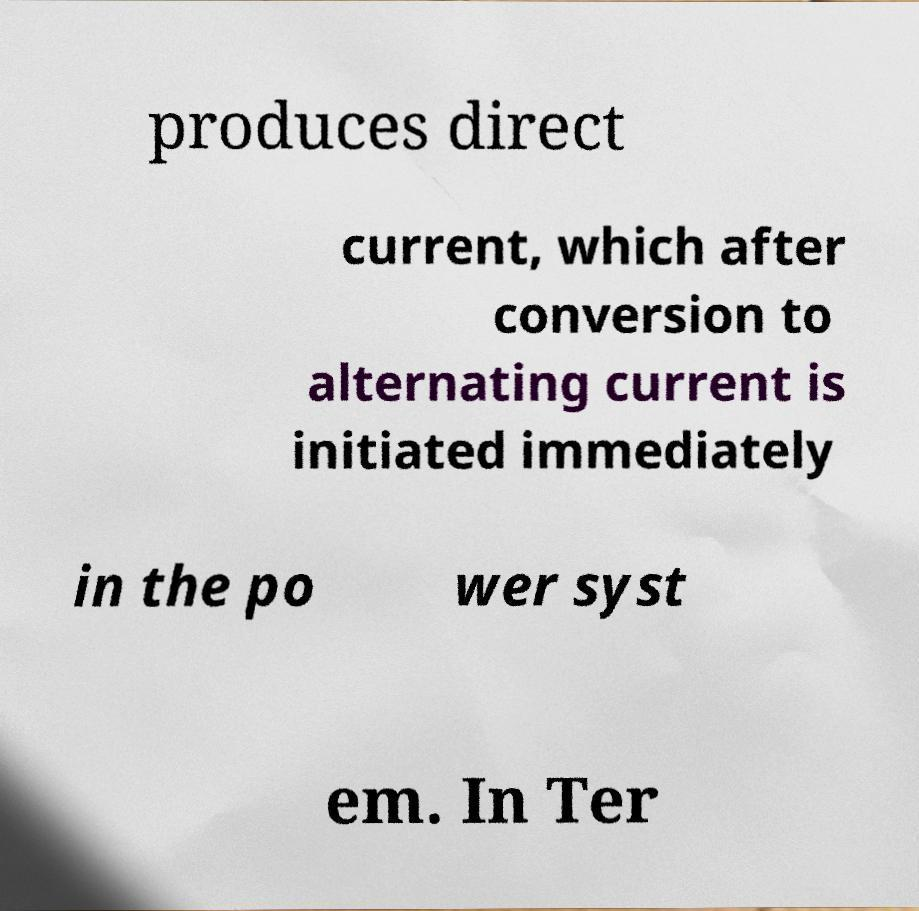What messages or text are displayed in this image? I need them in a readable, typed format. produces direct current, which after conversion to alternating current is initiated immediately in the po wer syst em. In Ter 